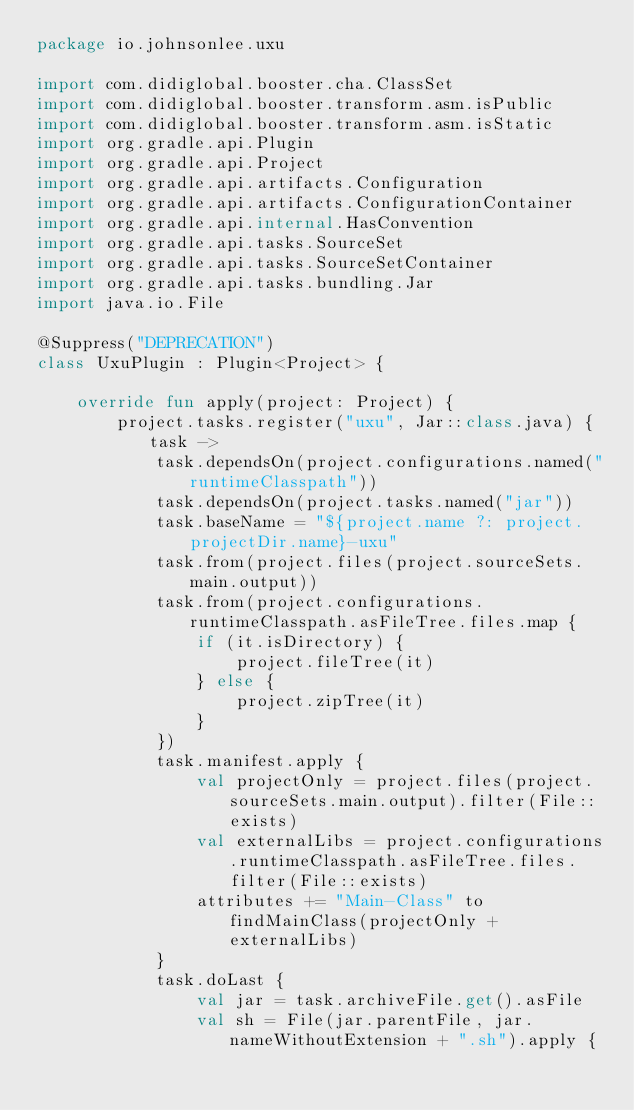<code> <loc_0><loc_0><loc_500><loc_500><_Kotlin_>package io.johnsonlee.uxu

import com.didiglobal.booster.cha.ClassSet
import com.didiglobal.booster.transform.asm.isPublic
import com.didiglobal.booster.transform.asm.isStatic
import org.gradle.api.Plugin
import org.gradle.api.Project
import org.gradle.api.artifacts.Configuration
import org.gradle.api.artifacts.ConfigurationContainer
import org.gradle.api.internal.HasConvention
import org.gradle.api.tasks.SourceSet
import org.gradle.api.tasks.SourceSetContainer
import org.gradle.api.tasks.bundling.Jar
import java.io.File

@Suppress("DEPRECATION")
class UxuPlugin : Plugin<Project> {

    override fun apply(project: Project) {
        project.tasks.register("uxu", Jar::class.java) { task ->
            task.dependsOn(project.configurations.named("runtimeClasspath"))
            task.dependsOn(project.tasks.named("jar"))
            task.baseName = "${project.name ?: project.projectDir.name}-uxu"
            task.from(project.files(project.sourceSets.main.output))
            task.from(project.configurations.runtimeClasspath.asFileTree.files.map {
                if (it.isDirectory) {
                    project.fileTree(it)
                } else {
                    project.zipTree(it)
                }
            })
            task.manifest.apply {
                val projectOnly = project.files(project.sourceSets.main.output).filter(File::exists)
                val externalLibs = project.configurations.runtimeClasspath.asFileTree.files.filter(File::exists)
                attributes += "Main-Class" to findMainClass(projectOnly + externalLibs)
            }
            task.doLast {
                val jar = task.archiveFile.get().asFile
                val sh = File(jar.parentFile, jar.nameWithoutExtension + ".sh").apply {</code> 